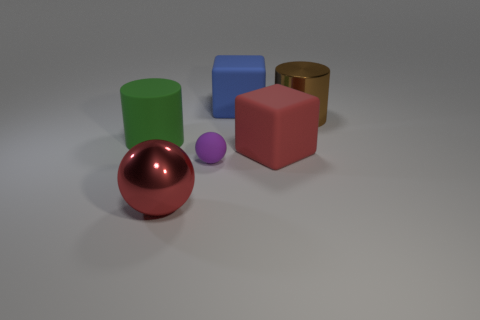Add 3 big brown things. How many objects exist? 9 Subtract 2 spheres. How many spheres are left? 0 Subtract all gray spheres. How many blue blocks are left? 1 Subtract all green rubber cylinders. Subtract all large brown metal things. How many objects are left? 4 Add 4 purple rubber spheres. How many purple rubber spheres are left? 5 Add 2 blue rubber objects. How many blue rubber objects exist? 3 Subtract 0 cyan blocks. How many objects are left? 6 Subtract all cylinders. How many objects are left? 4 Subtract all red spheres. Subtract all green cubes. How many spheres are left? 1 